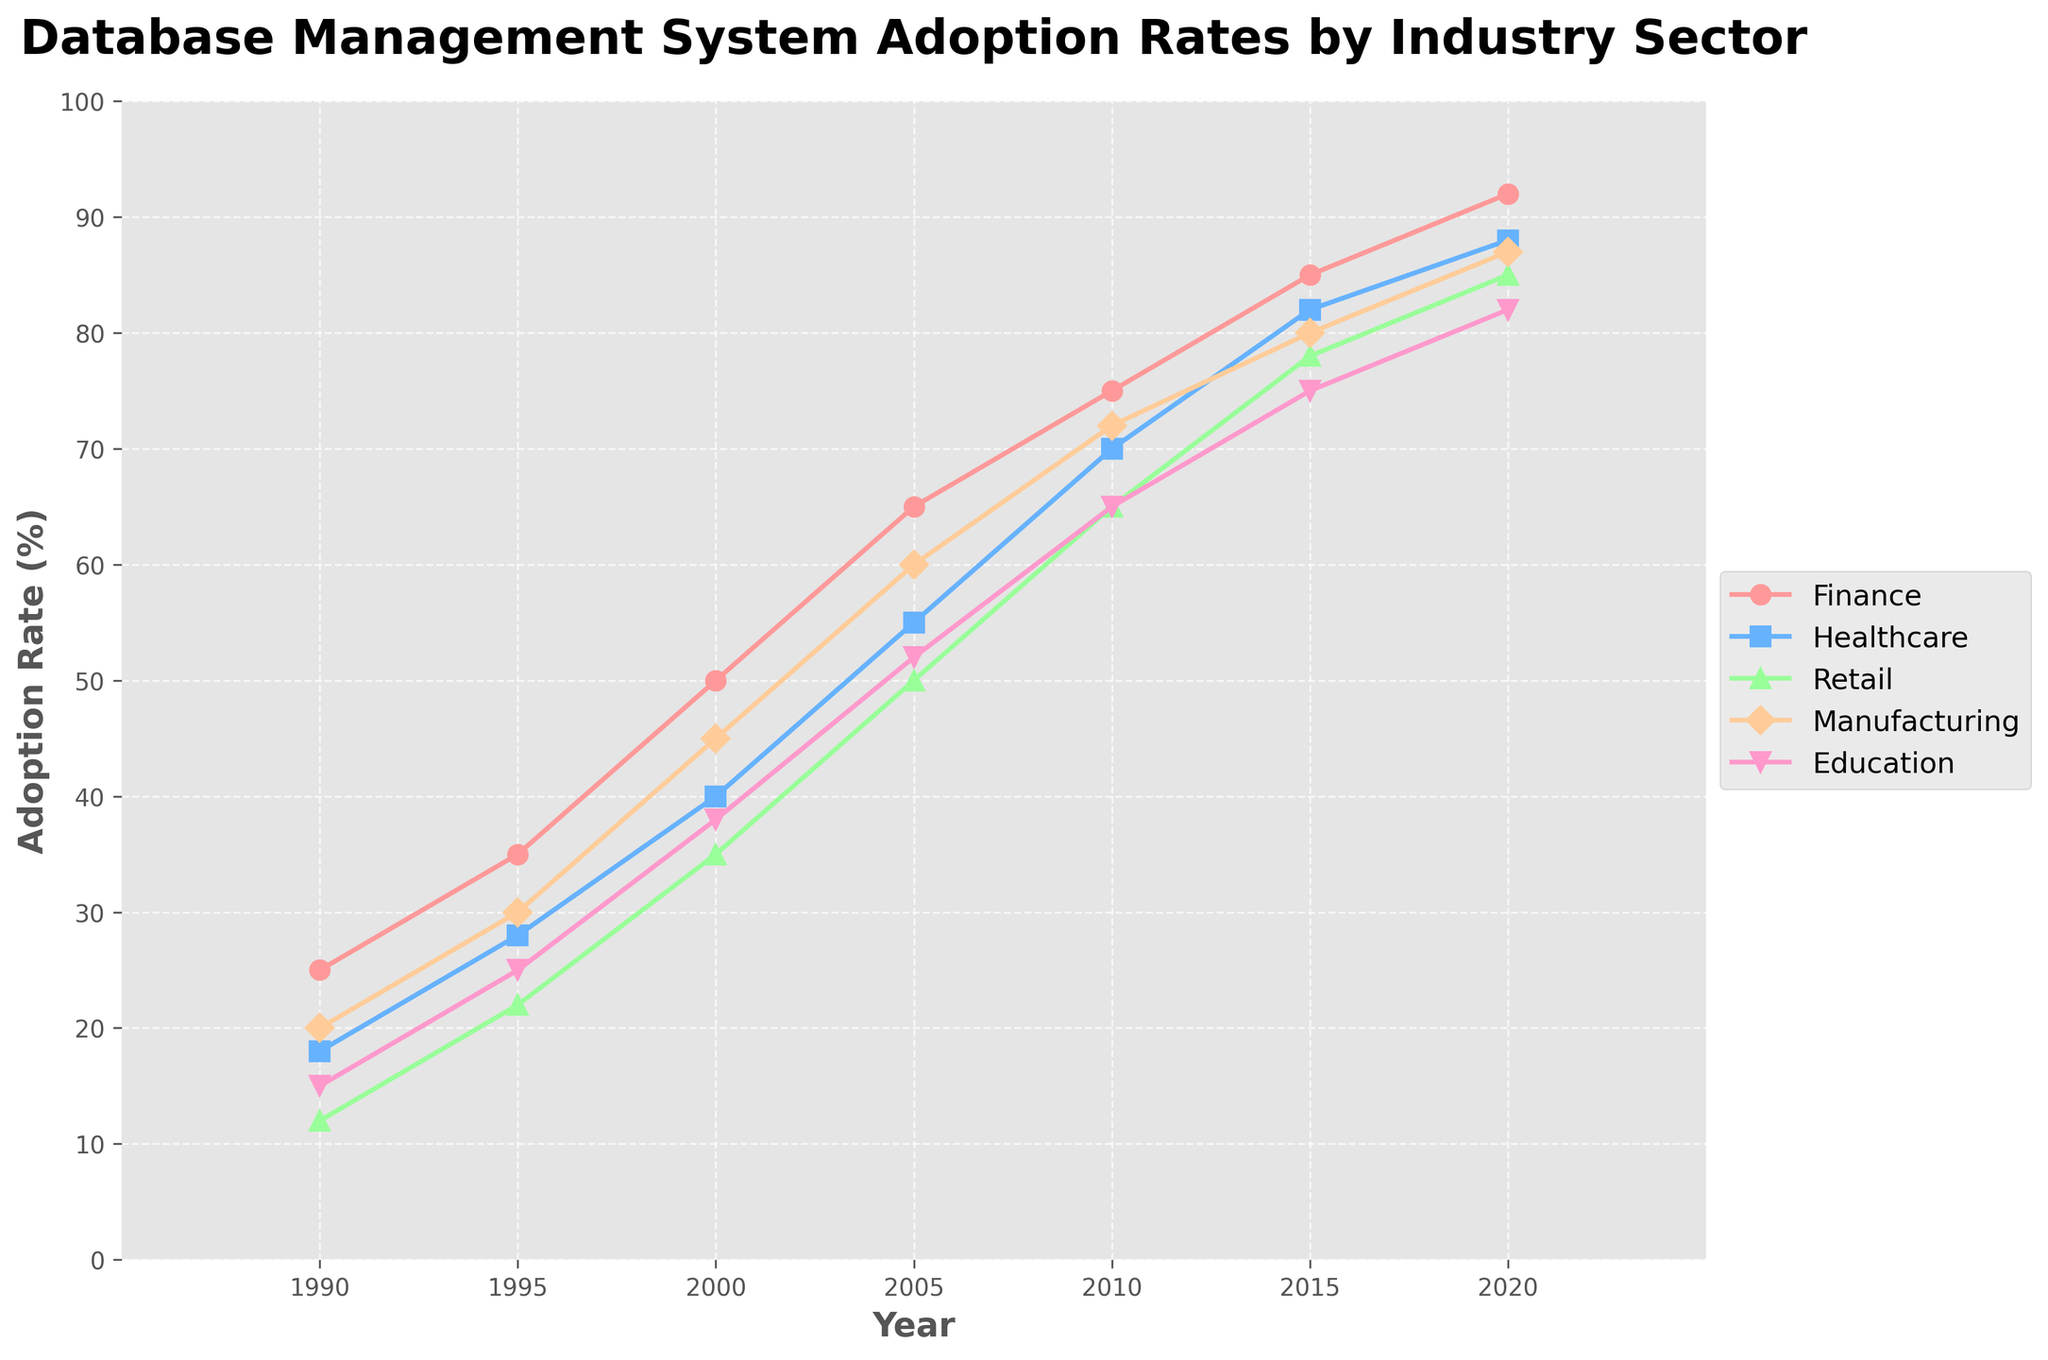What was the adoption rate of database management systems in the Finance sector in 2010? The Finance sector's adoption rate is represented by the red line on the chart. By locating the year 2010 on the x-axis and following it up to the red line, we can see that the adoption rate is 75%.
Answer: 75% Which sector had the highest adoption rate in 2000? By looking at the values for each sector in the year 2000, we observe that the Finance sector had the highest adoption rate of 50%, represented by the red line.
Answer: Finance How much did the adoption rate in the Healthcare sector increase from 1990 to 2020? The adoption rate for the Healthcare sector is depicted by the blue line. In 1990, the rate was 18%, and in 2020, it was 88%. The increase can be calculated as 88% - 18% = 70%.
Answer: 70% Compare the adoption rates of the Retail and Manufacturing sectors in 2015. Which sector had a higher rate and by how much? In 2015, the Retail sector had an adoption rate of 78% (green line), and the Manufacturing sector had a rate of 80% (orange line). Manufacturing had a higher rate, and the difference is calculated as 80% - 78% = 2%.
Answer: Manufacturing, 2% What trend can be observed for the Education sector between 1995 and 2020? Following the pink line from 1995 (25%) to 2020 (82%), we see a consistent upward trend in the adoption rate of database management systems in the Education sector.
Answer: Upward trend What is the average adoption rate across all sectors in 2010? To find the average, sum the adoption rates of all sectors in 2010: 75% (Finance) + 70% (Healthcare) + 65% (Retail) + 72% (Manufacturing) + 65% (Education) = 347%. Dividing by 5 sectors: 347% / 5 = 69.4%.
Answer: 69.4% Which sector experienced the largest increase in adoption rate from 1995 to 2005? Subtract the rates of 1995 from 2005 for each sector: Finance (65% - 35% = 30%), Healthcare (55% - 28% = 27%), Retail (50% - 22% = 28%), Manufacturing (60% - 30% = 30%), Education (52% - 25% = 27%). Both Finance and Manufacturing experienced the largest increase of 30%.
Answer: Finance and Manufacturing, 30% What can you infer about the adoption rate of database management systems in the Retail sector between 2000 and 2015? Observing the green line, the Retail sector's adoption rate increased from 35% in 2000 to 78% in 2015, indicating a significant rise. This can be interpreted as increased reliance on database management systems in the Retail sector during this period.
Answer: Significant rise How did the adoption rate for the Manufacturing sector change from 1990 to 2000, and then from 2000 to 2020? From 1990 (20%, orange line) to 2000 (45%) the increase is 25%. From 2000 (45%) to 2020 (87%), the increase is 42%. The rate increased first by 25% and then by 42%.
Answer: 25%, 42% What is the difference between the highest and lowest adoption rates in 2020? In 2020, the highest adoption rate is in Finance at 92%, and the lowest is in Education at 82%. The difference is 92% - 82% = 10%.
Answer: 10% 